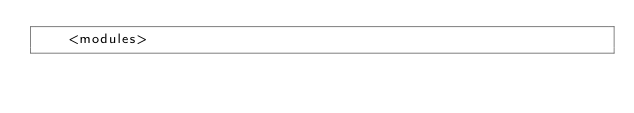Convert code to text. <code><loc_0><loc_0><loc_500><loc_500><_XML_>    <modules></code> 